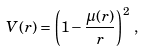<formula> <loc_0><loc_0><loc_500><loc_500>V ( r ) = \left ( 1 - \frac { \mu ( r ) } { r } \right ) ^ { 2 } \, ,</formula> 